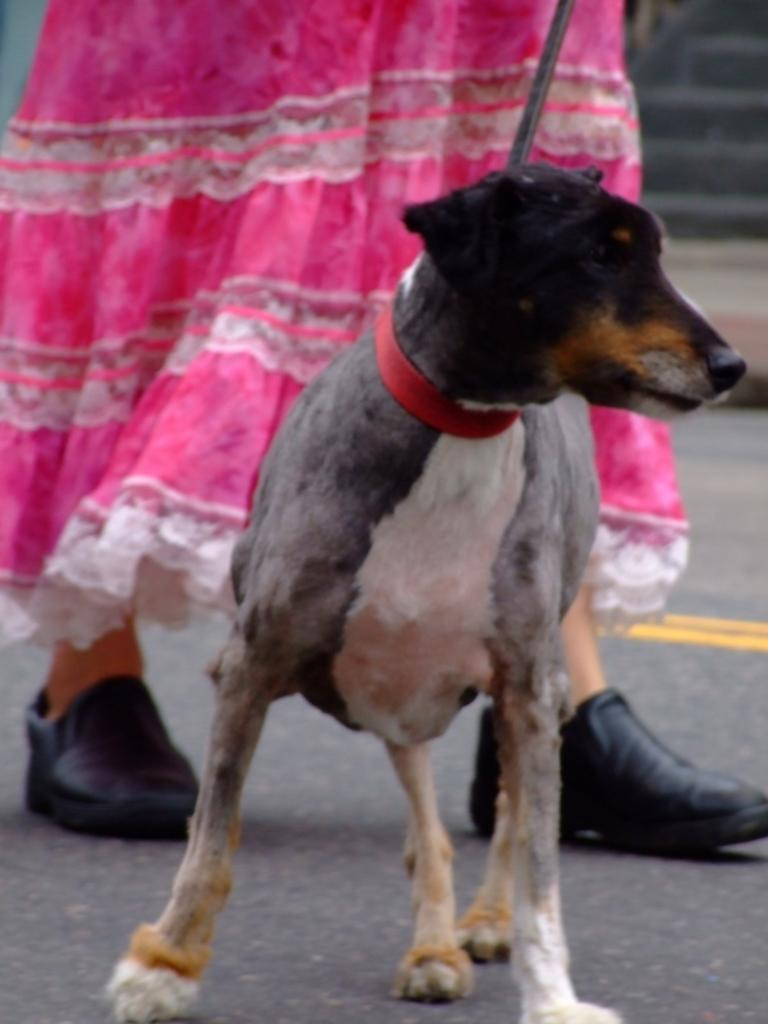What type of animal is in the image? There is a dog in the image. Where is the dog located in the image? The dog is standing on the road. What is the woman in the image doing? The woman is walking in the image. How is the woman positioned in relation to the dog? The woman is behind the dog. What type of jar is the expert holding during the rainstorm in the image? There is no jar or rainstorm present in the image; it features a dog standing on the road and a woman walking behind it. 